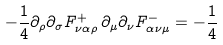Convert formula to latex. <formula><loc_0><loc_0><loc_500><loc_500>- { \frac { 1 } { 4 } } \partial _ { \rho } \partial _ { \sigma } F _ { \nu \alpha \rho } ^ { + } \, \partial _ { \mu } \partial _ { \nu } F _ { \alpha \nu \mu } ^ { - } = - { \frac { 1 } { 4 } }</formula> 